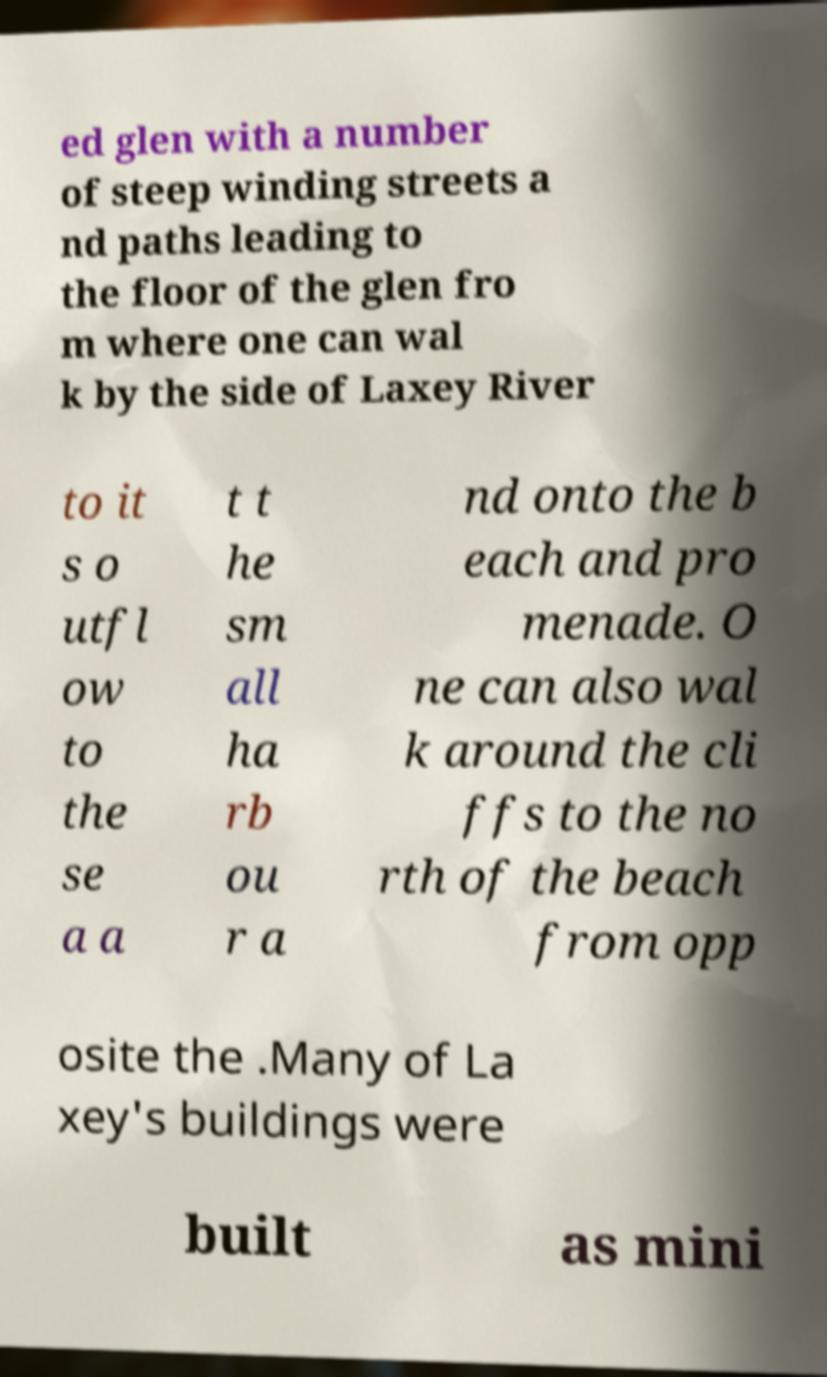Could you assist in decoding the text presented in this image and type it out clearly? ed glen with a number of steep winding streets a nd paths leading to the floor of the glen fro m where one can wal k by the side of Laxey River to it s o utfl ow to the se a a t t he sm all ha rb ou r a nd onto the b each and pro menade. O ne can also wal k around the cli ffs to the no rth of the beach from opp osite the .Many of La xey's buildings were built as mini 